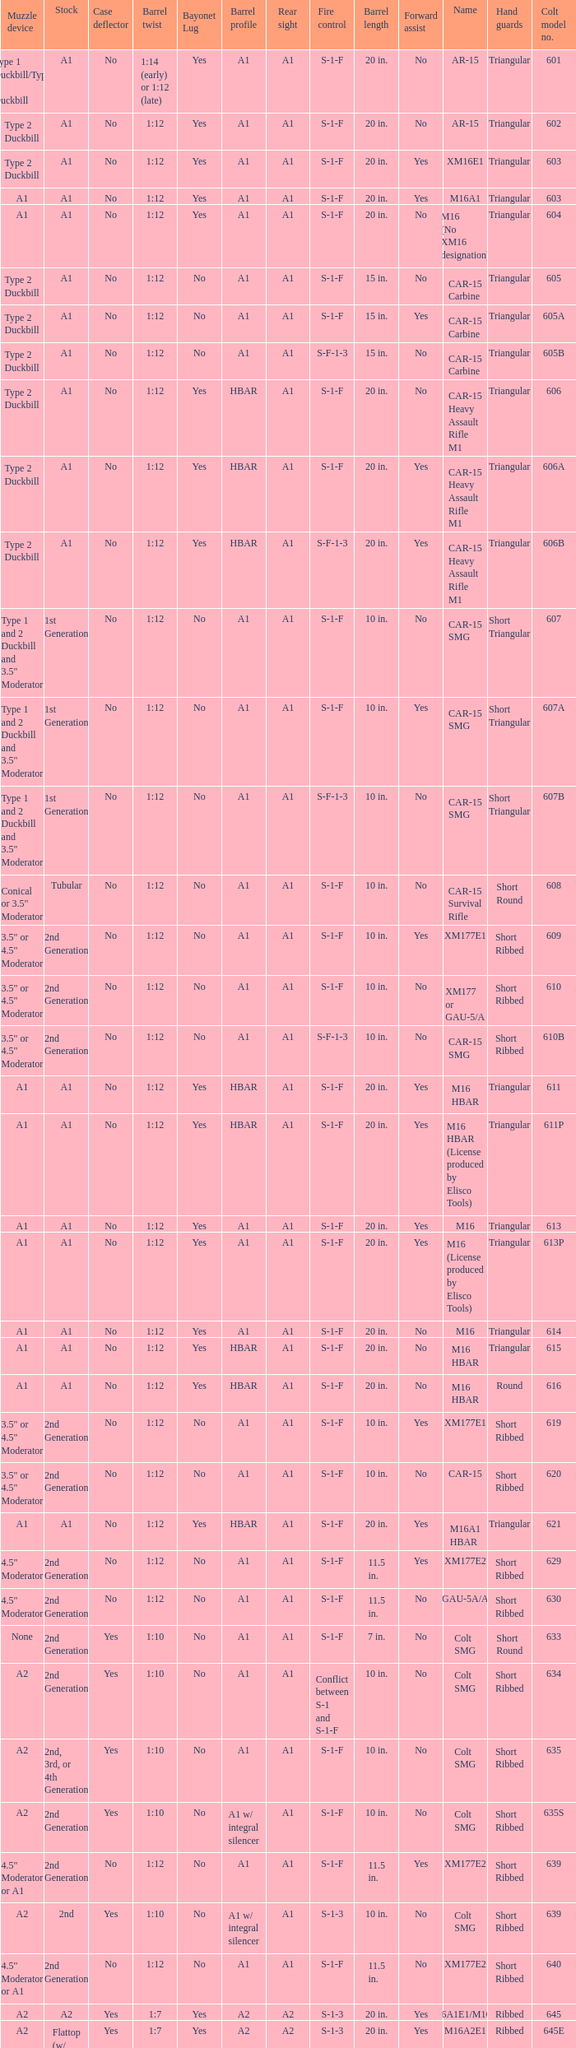What's the type of muzzle devices on the models with round hand guards? A1. Would you be able to parse every entry in this table? {'header': ['Muzzle device', 'Stock', 'Case deflector', 'Barrel twist', 'Bayonet Lug', 'Barrel profile', 'Rear sight', 'Fire control', 'Barrel length', 'Forward assist', 'Name', 'Hand guards', 'Colt model no.'], 'rows': [['Type 1 Duckbill/Type 2 Duckbill', 'A1', 'No', '1:14 (early) or 1:12 (late)', 'Yes', 'A1', 'A1', 'S-1-F', '20 in.', 'No', 'AR-15', 'Triangular', '601'], ['Type 2 Duckbill', 'A1', 'No', '1:12', 'Yes', 'A1', 'A1', 'S-1-F', '20 in.', 'No', 'AR-15', 'Triangular', '602'], ['Type 2 Duckbill', 'A1', 'No', '1:12', 'Yes', 'A1', 'A1', 'S-1-F', '20 in.', 'Yes', 'XM16E1', 'Triangular', '603'], ['A1', 'A1', 'No', '1:12', 'Yes', 'A1', 'A1', 'S-1-F', '20 in.', 'Yes', 'M16A1', 'Triangular', '603'], ['A1', 'A1', 'No', '1:12', 'Yes', 'A1', 'A1', 'S-1-F', '20 in.', 'No', 'M16 (No XM16 designation)', 'Triangular', '604'], ['Type 2 Duckbill', 'A1', 'No', '1:12', 'No', 'A1', 'A1', 'S-1-F', '15 in.', 'No', 'CAR-15 Carbine', 'Triangular', '605'], ['Type 2 Duckbill', 'A1', 'No', '1:12', 'No', 'A1', 'A1', 'S-1-F', '15 in.', 'Yes', 'CAR-15 Carbine', 'Triangular', '605A'], ['Type 2 Duckbill', 'A1', 'No', '1:12', 'No', 'A1', 'A1', 'S-F-1-3', '15 in.', 'No', 'CAR-15 Carbine', 'Triangular', '605B'], ['Type 2 Duckbill', 'A1', 'No', '1:12', 'Yes', 'HBAR', 'A1', 'S-1-F', '20 in.', 'No', 'CAR-15 Heavy Assault Rifle M1', 'Triangular', '606'], ['Type 2 Duckbill', 'A1', 'No', '1:12', 'Yes', 'HBAR', 'A1', 'S-1-F', '20 in.', 'Yes', 'CAR-15 Heavy Assault Rifle M1', 'Triangular', '606A'], ['Type 2 Duckbill', 'A1', 'No', '1:12', 'Yes', 'HBAR', 'A1', 'S-F-1-3', '20 in.', 'Yes', 'CAR-15 Heavy Assault Rifle M1', 'Triangular', '606B'], ['Type 1 and 2 Duckbill and 3.5" Moderator', '1st Generation', 'No', '1:12', 'No', 'A1', 'A1', 'S-1-F', '10 in.', 'No', 'CAR-15 SMG', 'Short Triangular', '607'], ['Type 1 and 2 Duckbill and 3.5" Moderator', '1st Generation', 'No', '1:12', 'No', 'A1', 'A1', 'S-1-F', '10 in.', 'Yes', 'CAR-15 SMG', 'Short Triangular', '607A'], ['Type 1 and 2 Duckbill and 3.5" Moderator', '1st Generation', 'No', '1:12', 'No', 'A1', 'A1', 'S-F-1-3', '10 in.', 'No', 'CAR-15 SMG', 'Short Triangular', '607B'], ['Conical or 3.5" Moderator', 'Tubular', 'No', '1:12', 'No', 'A1', 'A1', 'S-1-F', '10 in.', 'No', 'CAR-15 Survival Rifle', 'Short Round', '608'], ['3.5" or 4.5" Moderator', '2nd Generation', 'No', '1:12', 'No', 'A1', 'A1', 'S-1-F', '10 in.', 'Yes', 'XM177E1', 'Short Ribbed', '609'], ['3.5" or 4.5" Moderator', '2nd Generation', 'No', '1:12', 'No', 'A1', 'A1', 'S-1-F', '10 in.', 'No', 'XM177 or GAU-5/A', 'Short Ribbed', '610'], ['3.5" or 4.5" Moderator', '2nd Generation', 'No', '1:12', 'No', 'A1', 'A1', 'S-F-1-3', '10 in.', 'No', 'CAR-15 SMG', 'Short Ribbed', '610B'], ['A1', 'A1', 'No', '1:12', 'Yes', 'HBAR', 'A1', 'S-1-F', '20 in.', 'Yes', 'M16 HBAR', 'Triangular', '611'], ['A1', 'A1', 'No', '1:12', 'Yes', 'HBAR', 'A1', 'S-1-F', '20 in.', 'Yes', 'M16 HBAR (License produced by Elisco Tools)', 'Triangular', '611P'], ['A1', 'A1', 'No', '1:12', 'Yes', 'A1', 'A1', 'S-1-F', '20 in.', 'Yes', 'M16', 'Triangular', '613'], ['A1', 'A1', 'No', '1:12', 'Yes', 'A1', 'A1', 'S-1-F', '20 in.', 'Yes', 'M16 (License produced by Elisco Tools)', 'Triangular', '613P'], ['A1', 'A1', 'No', '1:12', 'Yes', 'A1', 'A1', 'S-1-F', '20 in.', 'No', 'M16', 'Triangular', '614'], ['A1', 'A1', 'No', '1:12', 'Yes', 'HBAR', 'A1', 'S-1-F', '20 in.', 'No', 'M16 HBAR', 'Triangular', '615'], ['A1', 'A1', 'No', '1:12', 'Yes', 'HBAR', 'A1', 'S-1-F', '20 in.', 'No', 'M16 HBAR', 'Round', '616'], ['3.5" or 4.5" Moderator', '2nd Generation', 'No', '1:12', 'No', 'A1', 'A1', 'S-1-F', '10 in.', 'Yes', 'XM177E1', 'Short Ribbed', '619'], ['3.5" or 4.5" Moderator', '2nd Generation', 'No', '1:12', 'No', 'A1', 'A1', 'S-1-F', '10 in.', 'No', 'CAR-15', 'Short Ribbed', '620'], ['A1', 'A1', 'No', '1:12', 'Yes', 'HBAR', 'A1', 'S-1-F', '20 in.', 'Yes', 'M16A1 HBAR', 'Triangular', '621'], ['4.5" Moderator', '2nd Generation', 'No', '1:12', 'No', 'A1', 'A1', 'S-1-F', '11.5 in.', 'Yes', 'XM177E2', 'Short Ribbed', '629'], ['4.5" Moderator', '2nd Generation', 'No', '1:12', 'No', 'A1', 'A1', 'S-1-F', '11.5 in.', 'No', 'GAU-5A/A', 'Short Ribbed', '630'], ['None', '2nd Generation', 'Yes', '1:10', 'No', 'A1', 'A1', 'S-1-F', '7 in.', 'No', 'Colt SMG', 'Short Round', '633'], ['A2', '2nd Generation', 'Yes', '1:10', 'No', 'A1', 'A1', 'Conflict between S-1 and S-1-F', '10 in.', 'No', 'Colt SMG', 'Short Ribbed', '634'], ['A2', '2nd, 3rd, or 4th Generation', 'Yes', '1:10', 'No', 'A1', 'A1', 'S-1-F', '10 in.', 'No', 'Colt SMG', 'Short Ribbed', '635'], ['A2', '2nd Generation', 'Yes', '1:10', 'No', 'A1 w/ integral silencer', 'A1', 'S-1-F', '10 in.', 'No', 'Colt SMG', 'Short Ribbed', '635S'], ['4.5" Moderator or A1', '2nd Generation', 'No', '1:12', 'No', 'A1', 'A1', 'S-1-F', '11.5 in.', 'Yes', 'XM177E2', 'Short Ribbed', '639'], ['A2', '2nd', 'Yes', '1:10', 'No', 'A1 w/ integral silencer', 'A1', 'S-1-3', '10 in.', 'No', 'Colt SMG', 'Short Ribbed', '639'], ['4.5" Moderator or A1', '2nd Generation', 'No', '1:12', 'No', 'A1', 'A1', 'S-1-F', '11.5 in.', 'No', 'XM177E2', 'Short Ribbed', '640'], ['A2', 'A2', 'Yes', '1:7', 'Yes', 'A2', 'A2', 'S-1-3', '20 in.', 'Yes', 'M16A1E1/M16A2', 'Ribbed', '645'], ['A2', 'Flattop (w/ flip down front sight)', 'Yes', '1:7', 'Yes', 'A2', 'A2', 'S-1-3', '20 in.', 'Yes', 'M16A2E1', 'Ribbed', '645E'], ['A2', 'A2', 'Yes', '1:7', 'Yes', 'A2', 'A2', 'S-1-F', '20 in.', 'Yes', 'M16A2E3/M16A3', 'Ribbed', '646'], ['4.5" Moderator', '2nd Generation', 'No', '1:12', 'No', 'A1', 'A1', 'S-1-F', '11.5 in.', 'No', 'GAU-5A/A', 'Short Ribbed', '649'], ['A1', 'A1', 'No', '1:12', 'Yes', 'A1', 'A1', 'S-1-F', '14.5 in.', 'Yes', 'M16A1 carbine', 'Short Ribbed', '650'], ['A1', 'A1', 'No', '1:12', 'Yes', 'A1', 'A1', 'S-1-F', '14.5 in.', 'Yes', 'M16A1 carbine', 'Short Ribbed', '651'], ['A1', 'A1', 'No', '1:12', 'Yes', 'A1', 'A1', 'S-1-F', '14.5 in.', 'No', 'M16A1 carbine', 'Short Ribbed', '652'], ['A1', '2nd Generation', 'No', '1:12', 'Yes', 'A1', 'A1', 'S-1-F', '14.5 in.', 'Yes', 'M16A1 carbine', 'Short Ribbed', '653'], ['A1', '2nd Generation', 'No', '1:12', 'Yes', 'A1', 'A1', 'S-1-F', '14.5 in.', 'Yes', 'M16A1 carbine (License produced by Elisco Tools)', 'Short Ribbed', '653P'], ['A1', '2nd Generation', 'No', '1:12', 'Yes', 'A1', 'A1', 'S-1-F', '14.5 in.', 'No', 'M16A1 carbine', 'Short Ribbed', '654'], ['A1', 'A1', 'No', '1:12', 'Yes', 'HBAR', 'Flattop', 'S-1-F', '20 in.', 'Yes', 'M16A1 Special Low Profile', 'Triangular', '656'], ['A2', 'A2', 'Yes', '1:7', 'Yes', 'A2', 'A2', 'S-1-F', '20 in.', 'Yes', 'M16A2', 'Ribbed', '701'], ['A2', 'A2', 'Yes', '1:7', 'Yes', 'A2', 'A2', 'S-1-3', '20 in.', 'Yes', 'M16A2', 'Ribbed', '702'], ['A2', 'A2', 'Yes', '1:7', 'Yes', 'A1', 'A2', 'S-1-F', '20 in.', 'Yes', 'M16A2', 'Ribbed', '703'], ['A2', 'A2', 'Yes', '1:7', 'Yes', 'A2', 'A2', 'S-1-3', '20 in.', 'Yes', 'M16A2', 'Ribbed', '705'], ['A2', 'A2', 'Yes', '1:7', 'Yes', 'A1', 'A2', 'S-1-3', '20 in.', 'Yes', 'M16A2', 'Ribbed', '707'], ['A2', 'A2', 'No and Yes', '1:7', 'Yes', 'A1', 'A1', 'S-1-F', '20 in.', 'Yes', 'M16A2', 'Ribbed', '711'], ['A2', 'A2', 'Yes', '1:7', 'Yes', 'A2', 'A2', 'S-1-3', '20 in.', 'Yes', 'M16A2', 'Ribbed', '713'], ['A2', 'A2', 'Yes', '1:7', 'Yes', 'A1', 'A2', 'S-1-3', '20 in.', 'Yes', 'M16A2', 'Ribbed', '719'], ['A2', '3rd Generation', 'Yes', '1:7', 'Yes', 'M4', 'A2', 'S-1-3', '14.5 in.', 'Yes', 'XM4 Carbine', 'Short Ribbed', '720'], ['A1', '3rd Generation', 'Yes', '1:7', 'Yes', 'A1', 'A1', 'S-1-F', '14.5 in.', 'Yes', 'M16A2 carbine', 'Short Ribbed', '723'], ['A2', '3rd Generation', 'Yes', '1:7', 'Yes', 'A1', 'A1', 'S-1-F', '14.5 in.', 'Yes', 'M16A2 carbine', 'Short Ribbed', '725A'], ['A2', '3rd Generation', 'Yes', '1:7', 'Yes', 'A2', 'A1', 'S-1-F', '14.5 in.', 'Yes', 'M16A2 carbine', 'Short Ribbed', '725B'], ['A1', '3rd Generation', 'Yes', '1:7', 'Yes', 'A1', 'A1', 'S-1-F', '14.5 in.', 'Yes', 'M16A2 carbine', 'Short Ribbed', '726'], ['A2', '3rd Generation', 'Yes', '1:7', 'Yes', 'M4', 'A2', 'S-1-F', '14.5 in.', 'Yes', 'M16A2 carbine', 'Short Ribbed', '727'], ['A2', '3rd Generation', 'Yes', '1:7', 'Yes', 'M4', 'A2', 'S-1-F', '14.5 in.', 'Yes', 'M16A2 carbine', 'Short Ribbed', '728'], ['A1 or A2', '3rd or 4th Generation', 'Yes or No', '1:7', 'No', 'A1 or A2', 'A1 or A2', 'S-1-F', '11.5 in.', 'Yes', 'M16A2 Commando / M4 Commando', 'Short Ribbed', '733'], ['A1 or A2', '3rd or 4th Generation', 'Yes or No', '1:7', 'No', 'A1 or A2', 'A1 or A2', 'S-1-3', '11.5 in.', 'Yes', 'M16A2 Commando / M4 Commando', 'Short Ribbed', '733A'], ['A1 or A2', '3rd Generation', 'Yes or No', '1:7', 'No', 'A1 or A2', 'A1 or A2', 'S-1-F', '11.5 in.', 'Yes', 'M16A2 Commando', 'Short Ribbed', '734'], ['A1 or A2', '3rd Generation', 'Yes or No', '1:7', 'No', 'A1 or A2', 'A1 or A2', 'S-1-3', '11.5 in.', 'Yes', 'M16A2 Commando', 'Short Ribbed', '734A'], ['A1 or A2', '3rd or 4th Generation', 'Yes or No', '1:7', 'No', 'A1 or A2', 'A1 or A2', 'S-1-3', '11.5 in.', 'Yes', 'M16A2 Commando / M4 Commando', 'Short Ribbed', '735'], ['A2', 'A2', 'Yes', '1:7', 'Yes', 'HBAR', 'A2', 'S-1-3', '20 in.', 'Yes', 'M16A2', 'Ribbed', '737'], ['A1 or A2', '4th Generation', 'Yes', '1:7', 'No', 'A2', 'A2', 'S-1-3-F', '11.5 in.', 'Yes', 'M4 Commando Enhanced', 'Short Ribbed', '738'], ['A2', 'A2', 'Yes', '1:7', 'Yes', 'HBAR', 'A2', 'S-1-F', '20 in.', 'Yes', 'M16A2', 'Ribbed', '741'], ['A2', 'A2', 'Yes', '1:7', 'Yes', 'HBAR', 'A2', 'S-1-F', '20 in.', 'Yes', 'M16A2 (Standard w/ bipod)', 'Ribbed', '742'], ['A2', 'A2', 'Yes', '1:7', 'Yes', 'HBAR', 'A2', 'S-1-3', '20 in.', 'Yes', 'M16A2 (Standard w/ bipod)', 'Ribbed', '745'], ['A2', 'A2', 'Yes', '1:7', 'Yes', 'HBAR', 'A2', 'S-1-3', '20 in.', 'Yes', 'M16A2 (Standard w/ bipod)', 'Ribbed', '746'], ['A2', 'A2', 'Yes', '1:7', 'Yes', 'HBAR', 'A2', 'S-F', '20 in.', 'Yes', 'LMG (Colt/ Diemaco project)', 'Square LMG', '750'], ['A2', '4th Generation', 'Yes', '1:7', 'Yes', 'M4', 'A2', 'S-1-3', '14.5 in.', 'Yes', 'M4 Carbine', 'M4', '777'], ['A2', '4th Generation', 'Yes', '1:7', 'Yes', 'M4', 'A2', 'S-1-3-F', '14.5 in.', 'Yes', 'M4 Carbine Enhanced', 'M4', '778'], ['A2', '4th Generation', 'Yes', '1:7', 'Yes', 'M4', 'A2', 'S-1-F', '14.5 in.', 'Yes', 'M4 Carbine', 'M4', '779'], ['A2', 'A2', 'Yes', '1:7', 'Yes', 'A2', 'Flattop', 'S-1-F', '20 in.', 'Yes', 'M16A3', 'Ribbed', '901'], ['A2', 'A2', 'Yes', '1:7', 'Yes', 'A2', 'Flattop', 'S-1-3', '20 in.', 'Yes', 'M16A4', 'Ribbed', '905'], ['A2', '3rd and 4th Generation', 'Yes', '1:7', 'Yes', 'M4', 'Flattop', 'S-1-3', '14.5 in.', 'Yes', 'M4 Carbine', 'M4', '920'], ['A2', '4th Generation', 'Yes', '1:7', 'Yes', 'M4', 'Flattop', 'S-1-F', '14.5 in.', 'Yes', 'M4E1/A1 Carbine', 'M4', '921'], ['A2', '4th Generation', 'Yes', '1:7', 'Yes', 'M4 HBAR', 'Flattop', 'S-1-F', '14.5 in.', 'Yes', 'M4A1 Carbine', 'M4', '921HB'], ['A2', '3rd or 4th Generation', 'Yes', '1:7', 'Yes', 'M4', 'Flattop', 'S-1-3', '14.5 in.', 'Yes', 'M4E2 Carbine', 'M4', '925'], ['A2', '4th Generation', 'Yes', '1:7', 'Yes', 'M4', 'Flattop', 'S-1-F', '14.5 in.', 'Yes', 'M4 Carbine', 'M4', '927'], ['A2', '4th Generation', 'Yes', '1:7', 'No', 'A1 or A2', 'Flattop', 'S-1-F', '11.5 in.', 'Yes', 'M4 Commando', 'Short Ribbed', '933'], ['A2', '4th Generation', 'Yes', '1:7', 'No', 'A1 or A2', 'Flattop', 'S-1-3', '11.5 in.', 'Yes', 'M4 Commando', 'Short Ribbed', '935'], ['A2', '4th Generation', 'Yes', '1:7', 'No', 'A2', 'Flattop', 'S-1-3-F', '11.5 in.', 'Yes', 'M4 Commando Enhanced', 'M4', '938'], ['A2', '4th Generation', 'Yes', '1:7', 'Yes', 'M4', 'Flattop', 'S-1-3', '14.5 in.', 'Yes', 'M4 Carbine', 'M4', '977'], ['A2', 'A2', 'Yes', '1:7', 'Yes', 'HBAR', 'Flattop', 'S-1-F', '20 in.', 'Yes', 'M16A3', 'Ribbed', '941'], ['A2', 'A2', 'Yes', '1:7', 'Yes', 'HBAR', 'Flattop', 'S-1-F', '20 in.', 'Yes', 'M16A3 (Standard w/ bipod)', 'Ribbed', '942'], ['A2', 'A2', 'Yes', '1:7', 'Yes', 'A2', 'Flattop', 'S-1-3', '20 in.', 'Yes', 'M16A2E4/M16A4', 'Ribbed', '945'], ['A2', 'A2', 'Yes', '1:7', 'Yes', 'HBAR', 'Flattop', 'S-F', '20 in.', 'Yes', 'LMG (Colt/ Diemaco project)', 'Square LMG', '950'], ['A2', '4th Generation', 'Yes', '1:7', 'Yes', 'M4', 'Flattop', 'S-1-3', '14.5 in.', 'Yes', 'M4 Carbine', 'M4', '"977"'], ['A2', '4th Generation', 'Yes', '1:7', 'Yes', 'M4', 'Flattop', 'S-1-3-F', '14.5 in.', 'Yes', 'M4 Carbine Enhanced', 'M4', '978'], ['A2', '4th Generation', 'Yes', '1:7', 'Yes', 'M4', 'Flattop', 'S-1-F', '14.5 in.', 'Yes', 'M4A1 Carbine', 'M4', '979']]} 